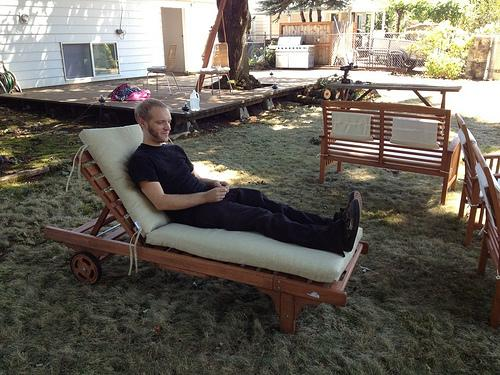Identify five distinct objects in the backyard and provide two adjectives for each of them. Wooden reclining lawn chair - comfortable, padded; Plastic bottle - clear, liquid-filled; Outside barbecue grill - metal, outdoors; Wooden bench - vacant, unoccupied; Green garden hose - coiled, useful. What kind of seats and furniture can you find in the yard, and are they occupied or unoccupied? Wooden reclining lawn chair (occupied by man), wooden bench with white cushions (unoccupied), brown and white chair (unknown occupancy status). Describe the scene depicted in the image with as much detail as possible. A man is laying on a wooden reclining lawn chair with a padded cushion in a backyard, with various outdoor furniture items, such as a wooden bench, white cushion, and grill. The surrounding area is covered in dried grass and there is a house with two windows. What is the man wearing while laying on the chaise lounge? The man is wearing a black shirt and black pants. Describe the condition of the ground in the image and the presence of vegetation. The ground is covered with dried grass clippings, and there does not seem to be a significant amount of vegetation apart from the large brown tree trunk. What does the man seem to be doing, and what type of chair is he laying on? The man appears to be relaxing on a wooden reclining lawn chair with a padded cushion and wheels at the head of it. Comment on the connection between the bench and the chaise lounge. The bench and the chaise lounge are both made of wood, and they are available in the backyard. However, while the bench is empty, the chaise lounge is currently in use by the man. 